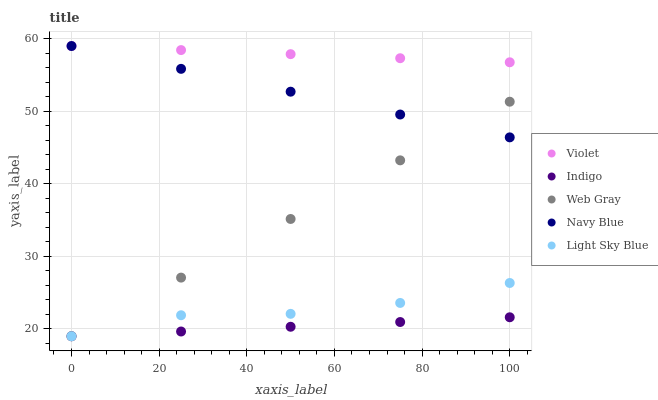Does Indigo have the minimum area under the curve?
Answer yes or no. Yes. Does Violet have the maximum area under the curve?
Answer yes or no. Yes. Does Web Gray have the minimum area under the curve?
Answer yes or no. No. Does Web Gray have the maximum area under the curve?
Answer yes or no. No. Is Indigo the smoothest?
Answer yes or no. Yes. Is Light Sky Blue the roughest?
Answer yes or no. Yes. Is Web Gray the smoothest?
Answer yes or no. No. Is Web Gray the roughest?
Answer yes or no. No. Does Web Gray have the lowest value?
Answer yes or no. Yes. Does Violet have the lowest value?
Answer yes or no. No. Does Violet have the highest value?
Answer yes or no. Yes. Does Web Gray have the highest value?
Answer yes or no. No. Is Light Sky Blue less than Violet?
Answer yes or no. Yes. Is Navy Blue greater than Indigo?
Answer yes or no. Yes. Does Navy Blue intersect Violet?
Answer yes or no. Yes. Is Navy Blue less than Violet?
Answer yes or no. No. Is Navy Blue greater than Violet?
Answer yes or no. No. Does Light Sky Blue intersect Violet?
Answer yes or no. No. 